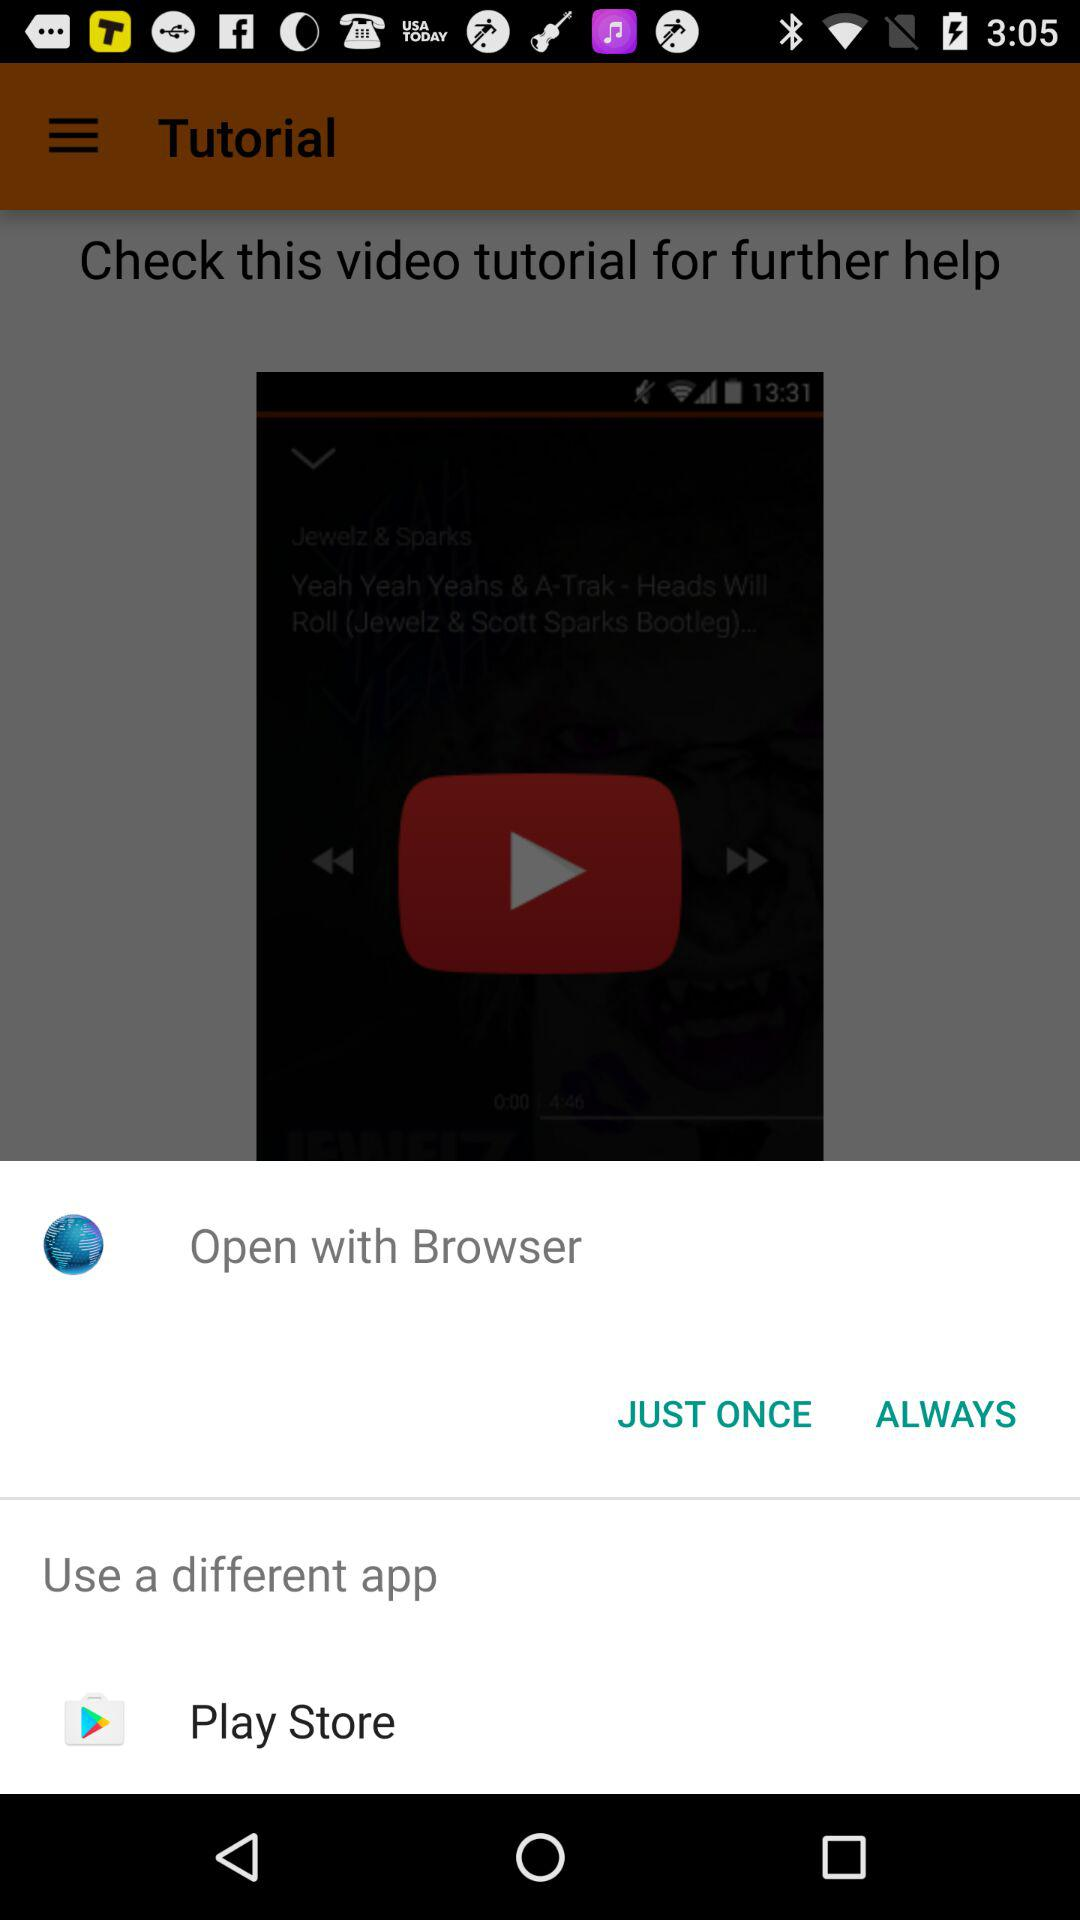What different options can be used to open it? The different options are "Browser" and "Play Store". 